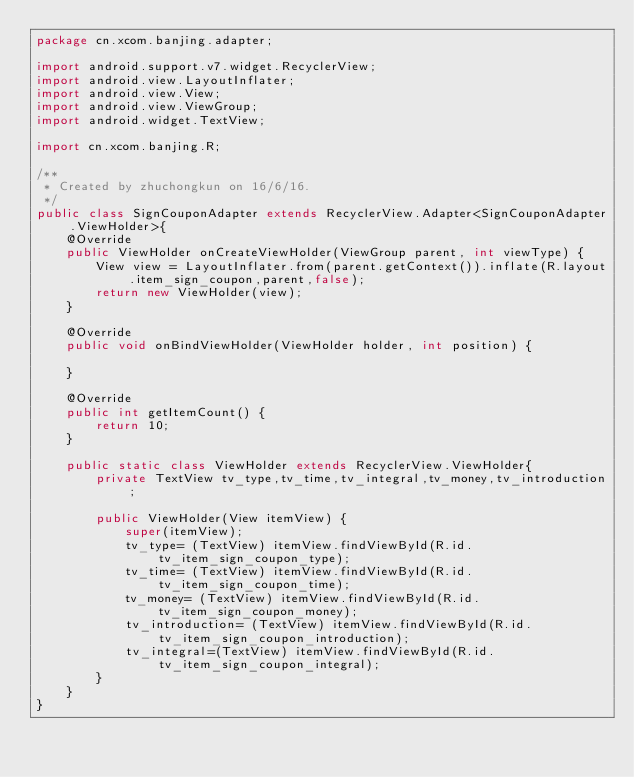Convert code to text. <code><loc_0><loc_0><loc_500><loc_500><_Java_>package cn.xcom.banjing.adapter;

import android.support.v7.widget.RecyclerView;
import android.view.LayoutInflater;
import android.view.View;
import android.view.ViewGroup;
import android.widget.TextView;

import cn.xcom.banjing.R;

/**
 * Created by zhuchongkun on 16/6/16.
 */
public class SignCouponAdapter extends RecyclerView.Adapter<SignCouponAdapter.ViewHolder>{
    @Override
    public ViewHolder onCreateViewHolder(ViewGroup parent, int viewType) {
        View view = LayoutInflater.from(parent.getContext()).inflate(R.layout.item_sign_coupon,parent,false);
        return new ViewHolder(view);
    }

    @Override
    public void onBindViewHolder(ViewHolder holder, int position) {

    }

    @Override
    public int getItemCount() {
        return 10;
    }

    public static class ViewHolder extends RecyclerView.ViewHolder{
        private TextView tv_type,tv_time,tv_integral,tv_money,tv_introduction;

        public ViewHolder(View itemView) {
            super(itemView);
            tv_type= (TextView) itemView.findViewById(R.id.tv_item_sign_coupon_type);
            tv_time= (TextView) itemView.findViewById(R.id.tv_item_sign_coupon_time);
            tv_money= (TextView) itemView.findViewById(R.id.tv_item_sign_coupon_money);
            tv_introduction= (TextView) itemView.findViewById(R.id.tv_item_sign_coupon_introduction);
            tv_integral=(TextView) itemView.findViewById(R.id.tv_item_sign_coupon_integral);
        }
    }
}
</code> 